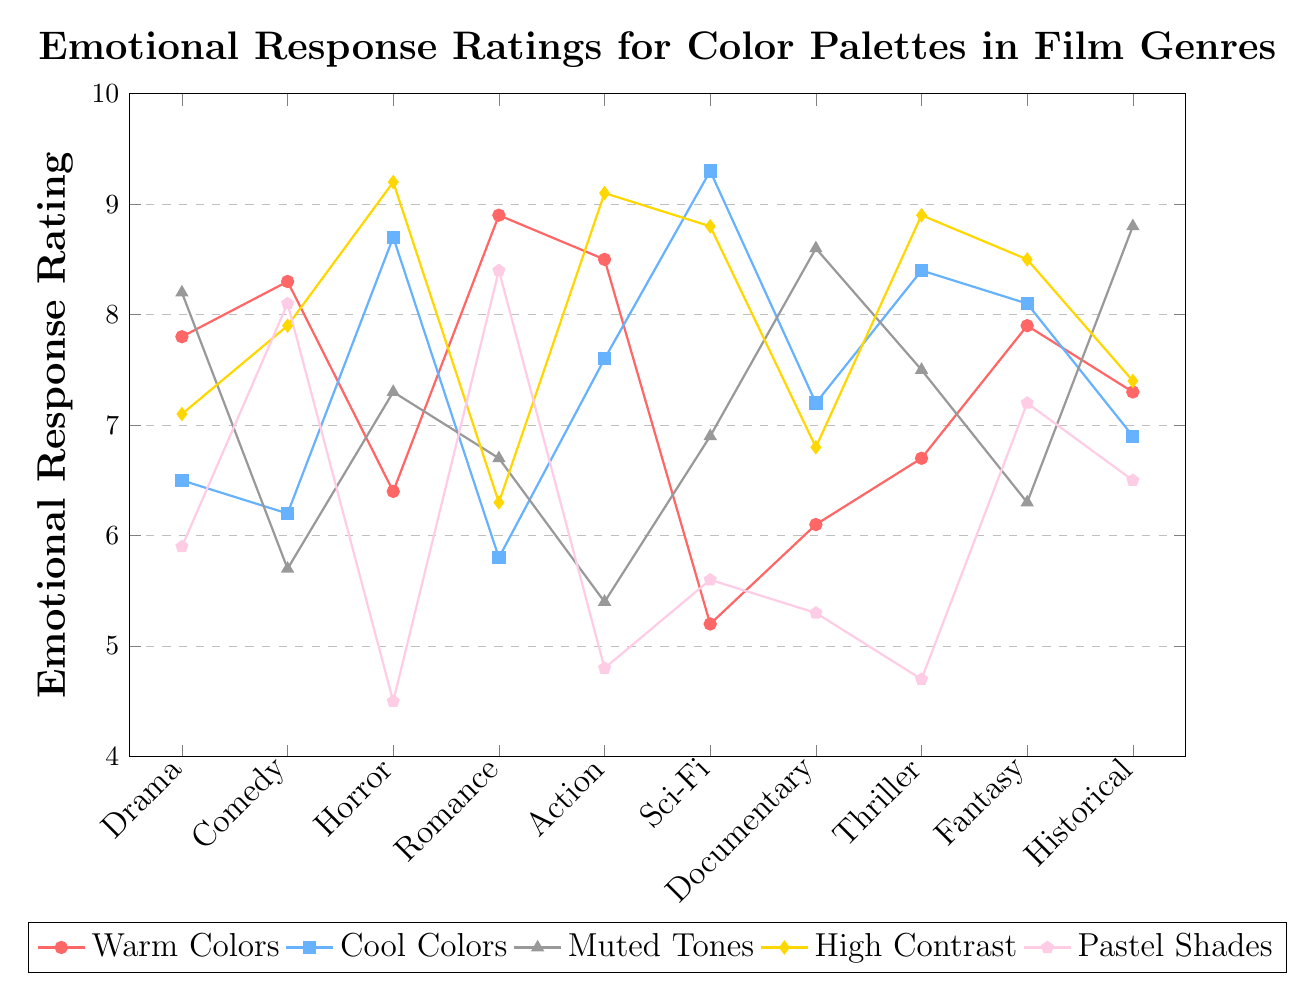Which film genre has the highest emotional response rating for cool colors? To determine the film genre with the highest emotional response rating for cool colors, look for the highest value along the cool colors line (colored in blue) and note the corresponding genre. The highest rating for cool colors is 9.3 in Sci-Fi.
Answer: Sci-Fi Which color palette has the lowest emotional response rating in the Horror genre? To find the lowest emotional response rating for Horror, look at each of the five color lines (warm, cool, muted, high contrast, and pastel) at the position corresponding to Horror and identify the lowest value. The lowest rating for Horror is 4.5 for pastel shades.
Answer: Pastel Shades What is the average emotional response rating for warm colors across all genres? Add up all the warm color ratings and divide by the number of genres. The sum of warm color ratings is 7.8 + 8.3 + 6.4 + 8.9 + 8.5 + 5.2 + 6.1 + 6.7 + 7.9 + 7.3 = 73.1. The number of genres is 10, so the average is 73.1 / 10 = 7.31.
Answer: 7.31 Compare the emotional response ratings for high contrast colors in Action and Comedy genres. Which is higher? Look at the high contrast color ratings for Action and Comedy genres (marked with diamond shapes). Action has a rating of 9.1, and Comedy has a rating of 7.9. Since 9.1 is greater than 7.9, Action has a higher rating.
Answer: Action Is the emotional response rating for muted tones in Historical genre higher or lower than that in Documentary genre? Check the muted tones' emotional response ratings for Historical and Documentary genres (marked by triangles). Historical has a rating of 8.8, and Documentary has a rating of 8.6. Since 8.8 is higher than 8.6, Historical is higher.
Answer: Higher Which film genre shows the highest variance in emotional response ratings across all color palettes? Calculate the variance of each genre by finding the range (difference between highest and lowest values) of ratings across all color palettes. For Drama: 8.2 - 5.9 = 2.3, Comedy: 8.3 - 5.7 = 2.6, Horror: 9.2 - 4.5 = 4.7, Romance: 8.9 - 5.8 = 3.1, Action: 9.1 - 4.8 = 4.3, Sci-Fi: 9.3 - 5.2 = 4.1, Documentary: 8.6 - 5.3 = 3.3, Thriller: 8.9 - 4.7 = 4.2, Fantasy: 8.5 - 6.3 = 2.2, Historical: 8.8 - 6.5 = 2.3. The highest variance is in the Horror genre.
Answer: Horror What is the combined emotional response rating for cool and high contrast colors in the Thriller genre? Add the emotional response rating for cool colors and high contrast colors in Thriller. Cool colors rating is 8.4 and high contrast rating is 8.9. The combined rating is 8.4 + 8.9 = 17.3.
Answer: 17.3 Which color palette has the most consistent emotional response rating across all genres? To determine consistency, look for the color palette line that has the smallest variations (or least steep slopes) across genres. Evaluate visually: Warm colors consistently hover around 7-8, Cool colors range from 5.8 to 9.3, Muted tones range from 5.4 to 8.8, High contrast ranges from 6.3 to 9.2, Pastel shades range from 4.5 to 8.4. Warm colors appear the most consistent.
Answer: Warm colors 